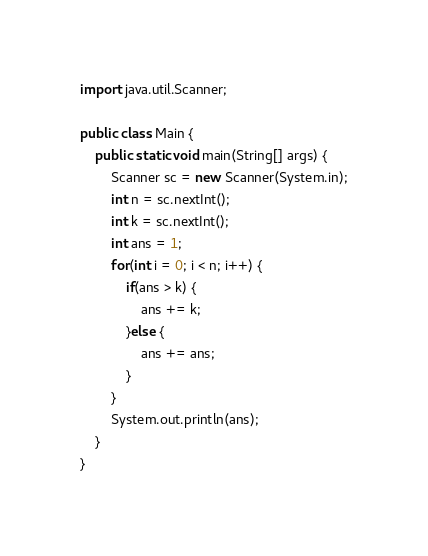Convert code to text. <code><loc_0><loc_0><loc_500><loc_500><_Java_>import java.util.Scanner;

public class Main {
	public static void main(String[] args) {
		Scanner sc = new Scanner(System.in);
		int n = sc.nextInt();
		int k = sc.nextInt();
		int ans = 1;
		for(int i = 0; i < n; i++) {
			if(ans > k) {
				ans += k;
			}else {
				ans += ans;
			}
		}
		System.out.println(ans);
	}
}
</code> 